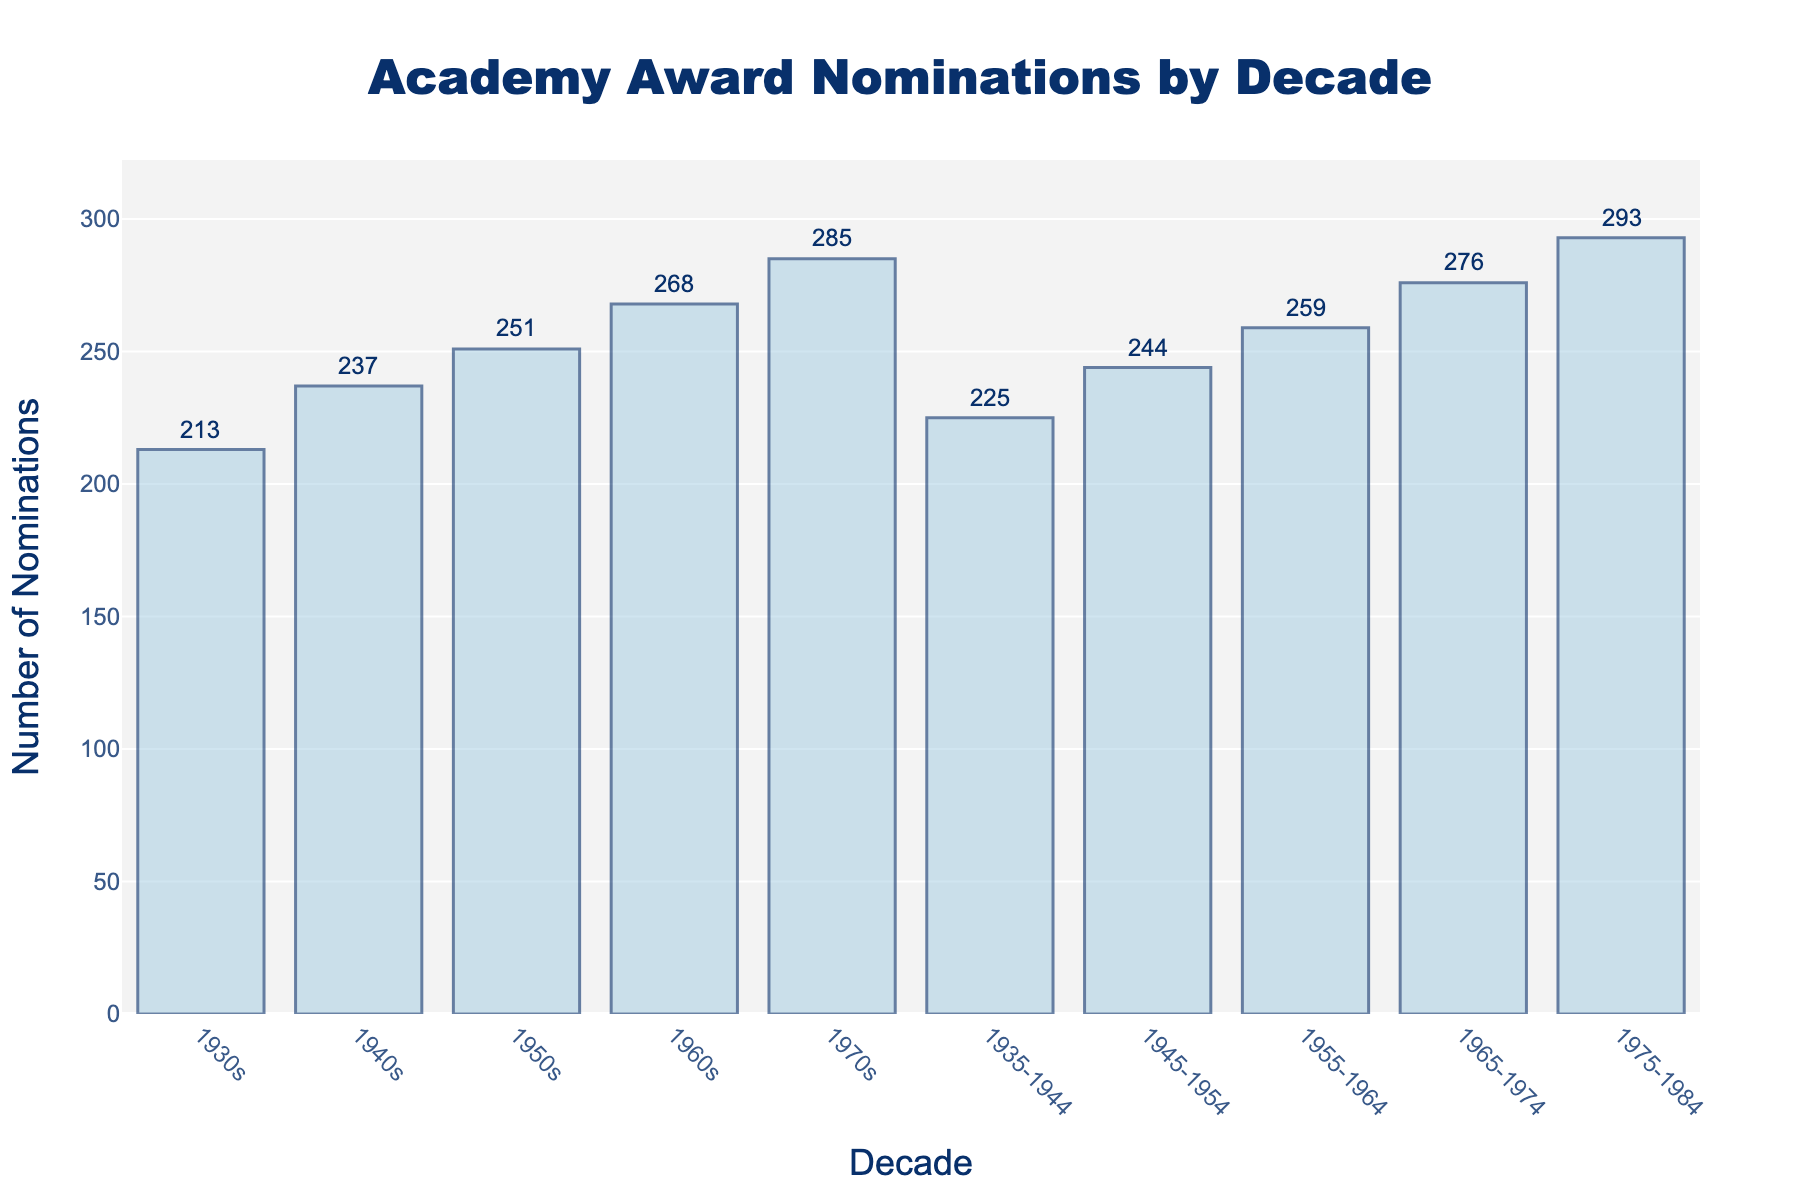Which decade has the highest number of Academy Award nominations? Look at the heights of the bars in the chart. The 1970s bar is the tallest, indicating the highest number of nominations.
Answer: 1970s Which decade has the lowest number of Academy Award nominations? Look for the shortest bar in the chart. The 1930s bar is the shortest, indicating the lowest number of nominations.
Answer: 1930s By how much did the Academy Award nominations increase from the 1930s to the 1970s? Subtract the number of nominations in the 1930s (213) from the number in the 1970s (285): 285 - 213 = 72.
Answer: 72 What is the average number of Academy Award nominations from the 1930s to the 1970s? Sum the nominations for each decade: 213 + 237 + 251 + 268 + 285 = 1254. There are 5 decades, so divide by 5: 1254 / 5 = 250.8.
Answer: 250.8 Which decade saw the largest increase in nominations compared to the previous one? Calculate the differences between successive decades: 
1940s - 1930s = 237 - 213 = 24,
1950s - 1940s = 251 - 237 = 14,
1960s - 1950s = 268 - 251 = 17,
1970s - 1960s = 285 - 268 = 17.
The 1940s had the largest increase of 24 nominations compared to the 1930s.
Answer: 1940s How did the number of Academy Award nominations change between the 1955-1964 period and the 1965-1974 period? Subtract the nominations for 1955-1964 (259) from the nominations for 1965-1974 (276): 276 - 259 = 17.
Answer: Increase by 17 What is the range of Academy Award nominations across all decades? Identify the highest and lowest nomination counts: Highest is 285 (1970s), and lowest is 213 (1930s). Subtract the lowest from the highest: 285 - 213 = 72.
Answer: 72 Is there any period with more nominations than the 1970s? Compare each period's nominations with the 1970s (285). The 1975-1984 period has 293 nominations, which is more.
Answer: Yes How does the number of nominations in the 1950s compare to those in the period 1935-1944? Compare the two values: 1950s (251) vs. 1935-1944 (225). The 1950s have more nominations.
Answer: The 1950s have more By what percentage did the nominations increase from the 1930s to the 1970s? Calculate the increase in nominations: 285 - 213 = 72. Then, divide by the number of nominations in the 1930s and multiply by 100 to get the percentage: (72 / 213) * 100 ≈ 33.8%.
Answer: ~33.8% 